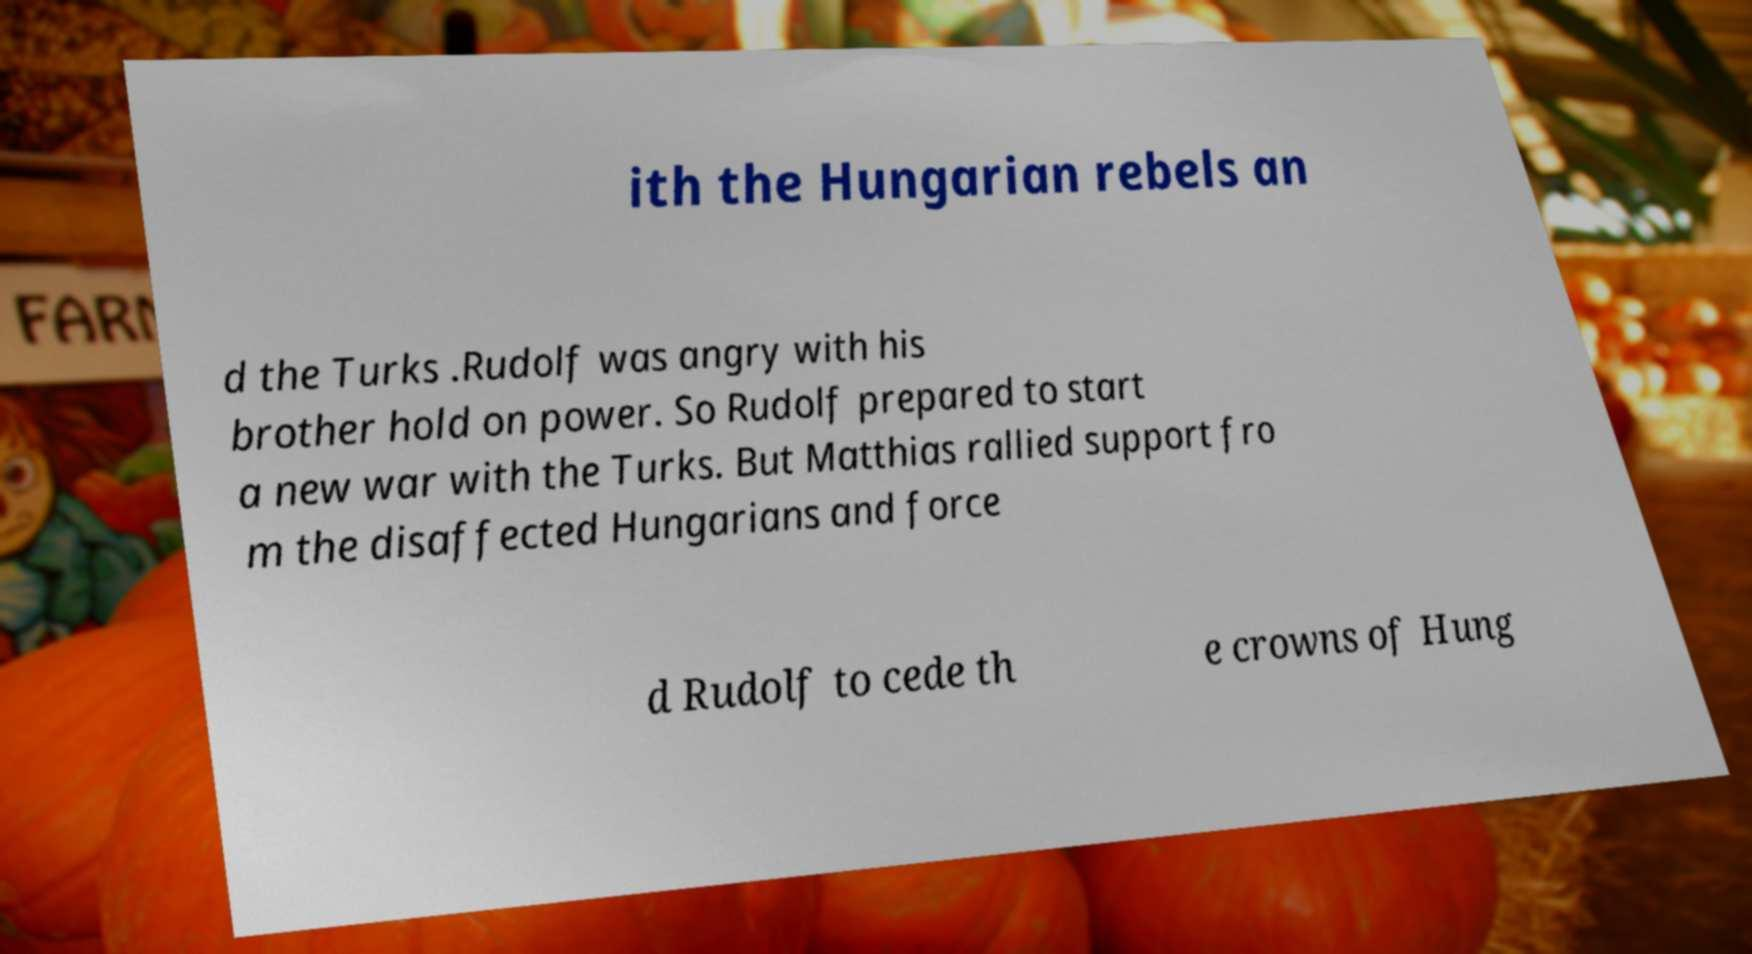Please read and relay the text visible in this image. What does it say? ith the Hungarian rebels an d the Turks .Rudolf was angry with his brother hold on power. So Rudolf prepared to start a new war with the Turks. But Matthias rallied support fro m the disaffected Hungarians and force d Rudolf to cede th e crowns of Hung 